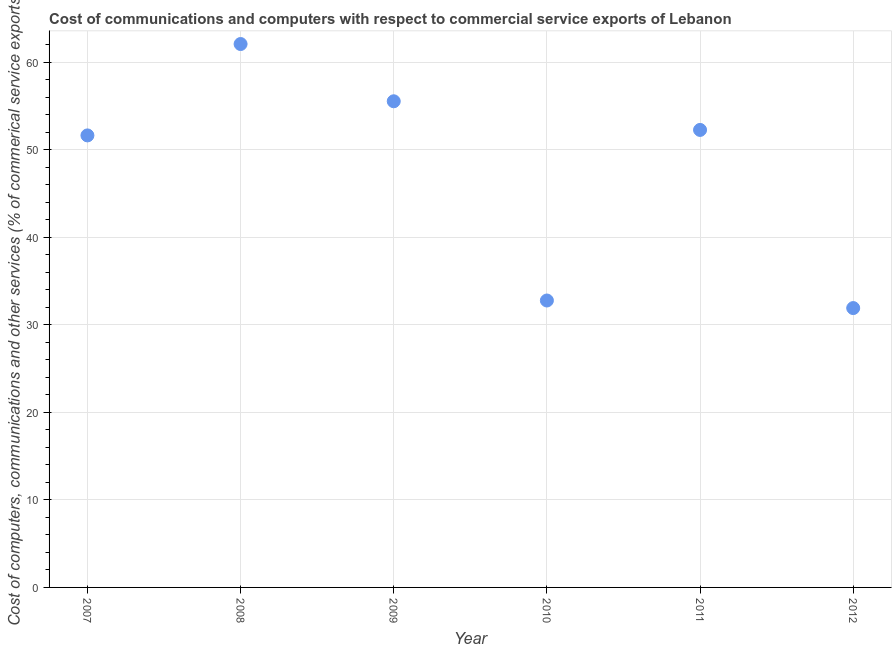What is the  computer and other services in 2011?
Your response must be concise. 52.26. Across all years, what is the maximum  computer and other services?
Give a very brief answer. 62.07. Across all years, what is the minimum  computer and other services?
Provide a short and direct response. 31.91. In which year was the cost of communications maximum?
Ensure brevity in your answer.  2008. What is the sum of the cost of communications?
Your answer should be very brief. 286.16. What is the difference between the  computer and other services in 2010 and 2011?
Your answer should be compact. -19.48. What is the average cost of communications per year?
Your answer should be very brief. 47.69. What is the median  computer and other services?
Offer a very short reply. 51.94. In how many years, is the cost of communications greater than 50 %?
Ensure brevity in your answer.  4. Do a majority of the years between 2009 and 2010 (inclusive) have cost of communications greater than 16 %?
Provide a succinct answer. Yes. What is the ratio of the cost of communications in 2007 to that in 2009?
Provide a short and direct response. 0.93. What is the difference between the highest and the second highest cost of communications?
Provide a succinct answer. 6.54. What is the difference between the highest and the lowest cost of communications?
Give a very brief answer. 30.16. How many years are there in the graph?
Offer a terse response. 6. What is the difference between two consecutive major ticks on the Y-axis?
Ensure brevity in your answer.  10. Are the values on the major ticks of Y-axis written in scientific E-notation?
Offer a terse response. No. Does the graph contain any zero values?
Your answer should be compact. No. Does the graph contain grids?
Provide a short and direct response. Yes. What is the title of the graph?
Provide a short and direct response. Cost of communications and computers with respect to commercial service exports of Lebanon. What is the label or title of the Y-axis?
Offer a very short reply. Cost of computers, communications and other services (% of commerical service exports). What is the Cost of computers, communications and other services (% of commerical service exports) in 2007?
Offer a very short reply. 51.63. What is the Cost of computers, communications and other services (% of commerical service exports) in 2008?
Offer a terse response. 62.07. What is the Cost of computers, communications and other services (% of commerical service exports) in 2009?
Offer a very short reply. 55.53. What is the Cost of computers, communications and other services (% of commerical service exports) in 2010?
Make the answer very short. 32.77. What is the Cost of computers, communications and other services (% of commerical service exports) in 2011?
Your response must be concise. 52.26. What is the Cost of computers, communications and other services (% of commerical service exports) in 2012?
Ensure brevity in your answer.  31.91. What is the difference between the Cost of computers, communications and other services (% of commerical service exports) in 2007 and 2008?
Keep it short and to the point. -10.44. What is the difference between the Cost of computers, communications and other services (% of commerical service exports) in 2007 and 2009?
Your answer should be compact. -3.9. What is the difference between the Cost of computers, communications and other services (% of commerical service exports) in 2007 and 2010?
Keep it short and to the point. 18.86. What is the difference between the Cost of computers, communications and other services (% of commerical service exports) in 2007 and 2011?
Make the answer very short. -0.63. What is the difference between the Cost of computers, communications and other services (% of commerical service exports) in 2007 and 2012?
Offer a very short reply. 19.72. What is the difference between the Cost of computers, communications and other services (% of commerical service exports) in 2008 and 2009?
Your answer should be compact. 6.54. What is the difference between the Cost of computers, communications and other services (% of commerical service exports) in 2008 and 2010?
Give a very brief answer. 29.29. What is the difference between the Cost of computers, communications and other services (% of commerical service exports) in 2008 and 2011?
Offer a very short reply. 9.81. What is the difference between the Cost of computers, communications and other services (% of commerical service exports) in 2008 and 2012?
Offer a very short reply. 30.16. What is the difference between the Cost of computers, communications and other services (% of commerical service exports) in 2009 and 2010?
Your answer should be very brief. 22.76. What is the difference between the Cost of computers, communications and other services (% of commerical service exports) in 2009 and 2011?
Offer a terse response. 3.27. What is the difference between the Cost of computers, communications and other services (% of commerical service exports) in 2009 and 2012?
Your response must be concise. 23.62. What is the difference between the Cost of computers, communications and other services (% of commerical service exports) in 2010 and 2011?
Provide a succinct answer. -19.48. What is the difference between the Cost of computers, communications and other services (% of commerical service exports) in 2010 and 2012?
Give a very brief answer. 0.87. What is the difference between the Cost of computers, communications and other services (% of commerical service exports) in 2011 and 2012?
Give a very brief answer. 20.35. What is the ratio of the Cost of computers, communications and other services (% of commerical service exports) in 2007 to that in 2008?
Keep it short and to the point. 0.83. What is the ratio of the Cost of computers, communications and other services (% of commerical service exports) in 2007 to that in 2009?
Offer a terse response. 0.93. What is the ratio of the Cost of computers, communications and other services (% of commerical service exports) in 2007 to that in 2010?
Offer a very short reply. 1.57. What is the ratio of the Cost of computers, communications and other services (% of commerical service exports) in 2007 to that in 2011?
Offer a terse response. 0.99. What is the ratio of the Cost of computers, communications and other services (% of commerical service exports) in 2007 to that in 2012?
Your response must be concise. 1.62. What is the ratio of the Cost of computers, communications and other services (% of commerical service exports) in 2008 to that in 2009?
Provide a succinct answer. 1.12. What is the ratio of the Cost of computers, communications and other services (% of commerical service exports) in 2008 to that in 2010?
Keep it short and to the point. 1.89. What is the ratio of the Cost of computers, communications and other services (% of commerical service exports) in 2008 to that in 2011?
Your response must be concise. 1.19. What is the ratio of the Cost of computers, communications and other services (% of commerical service exports) in 2008 to that in 2012?
Your answer should be compact. 1.95. What is the ratio of the Cost of computers, communications and other services (% of commerical service exports) in 2009 to that in 2010?
Keep it short and to the point. 1.69. What is the ratio of the Cost of computers, communications and other services (% of commerical service exports) in 2009 to that in 2011?
Keep it short and to the point. 1.06. What is the ratio of the Cost of computers, communications and other services (% of commerical service exports) in 2009 to that in 2012?
Your response must be concise. 1.74. What is the ratio of the Cost of computers, communications and other services (% of commerical service exports) in 2010 to that in 2011?
Your response must be concise. 0.63. What is the ratio of the Cost of computers, communications and other services (% of commerical service exports) in 2010 to that in 2012?
Offer a very short reply. 1.03. What is the ratio of the Cost of computers, communications and other services (% of commerical service exports) in 2011 to that in 2012?
Your response must be concise. 1.64. 